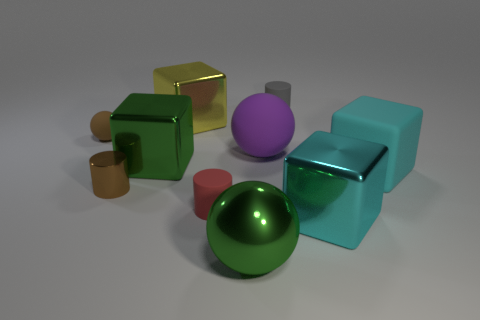Subtract all spheres. How many objects are left? 7 Add 8 large yellow metallic cubes. How many large yellow metallic cubes are left? 9 Add 6 big rubber objects. How many big rubber objects exist? 8 Subtract 1 gray cylinders. How many objects are left? 9 Subtract all shiny cylinders. Subtract all large purple objects. How many objects are left? 8 